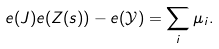<formula> <loc_0><loc_0><loc_500><loc_500>e ( J ) e ( Z ( s ) ) - e ( \mathcal { Y } ) = \sum _ { i } \mu _ { i } .</formula> 